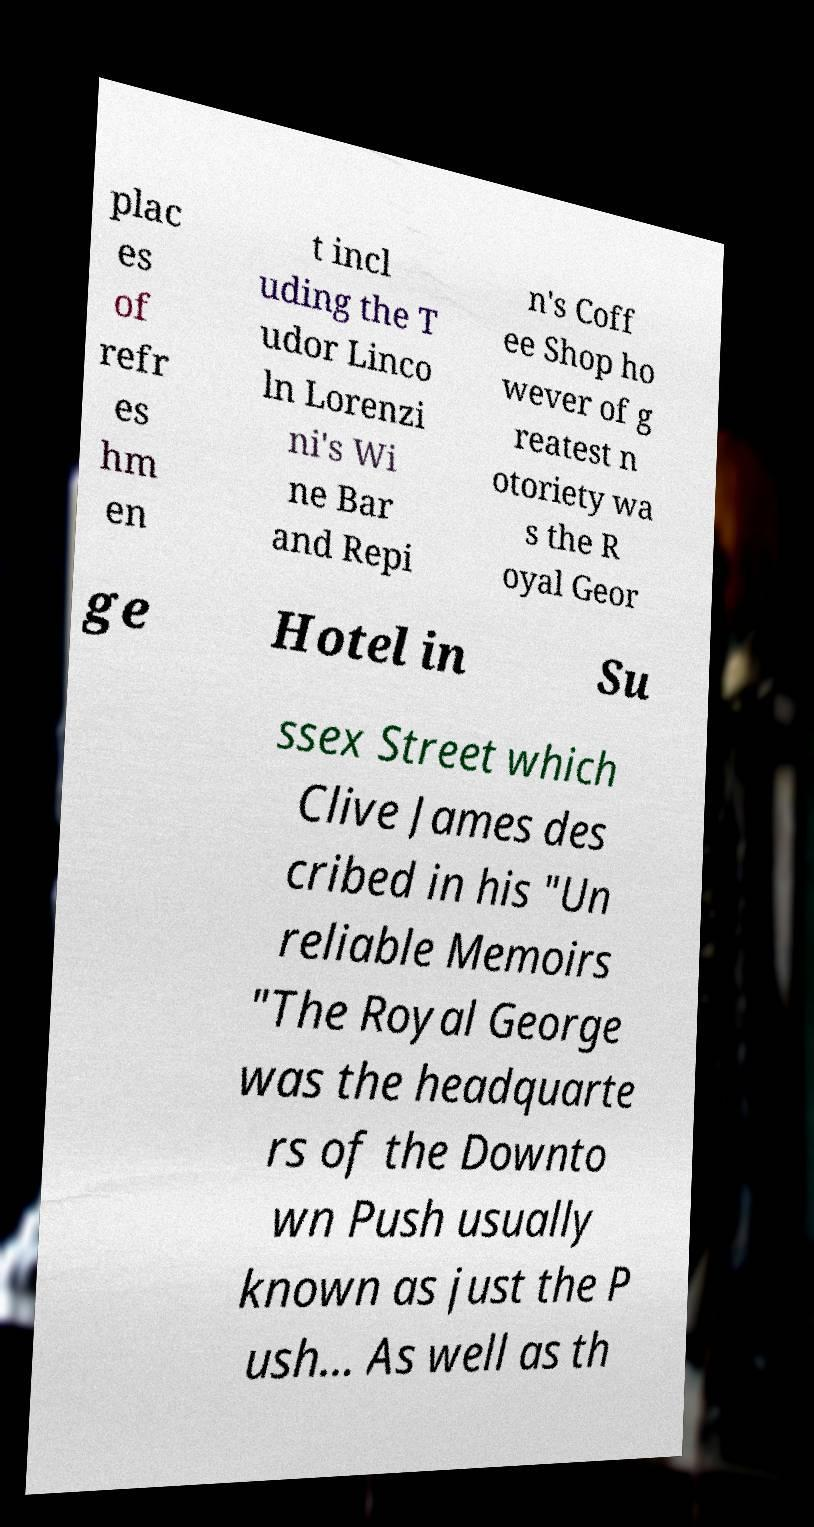Can you accurately transcribe the text from the provided image for me? plac es of refr es hm en t incl uding the T udor Linco ln Lorenzi ni's Wi ne Bar and Repi n's Coff ee Shop ho wever of g reatest n otoriety wa s the R oyal Geor ge Hotel in Su ssex Street which Clive James des cribed in his "Un reliable Memoirs "The Royal George was the headquarte rs of the Downto wn Push usually known as just the P ush... As well as th 